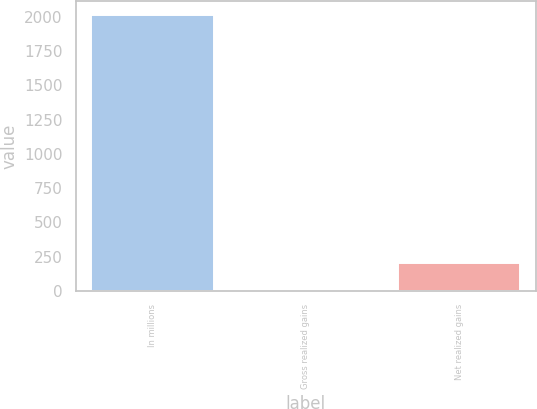<chart> <loc_0><loc_0><loc_500><loc_500><bar_chart><fcel>In millions<fcel>Gross realized gains<fcel>Net realized gains<nl><fcel>2014<fcel>0.6<fcel>201.94<nl></chart> 